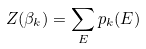<formula> <loc_0><loc_0><loc_500><loc_500>Z ( \beta _ { k } ) = \sum _ { E } p _ { k } ( E )</formula> 